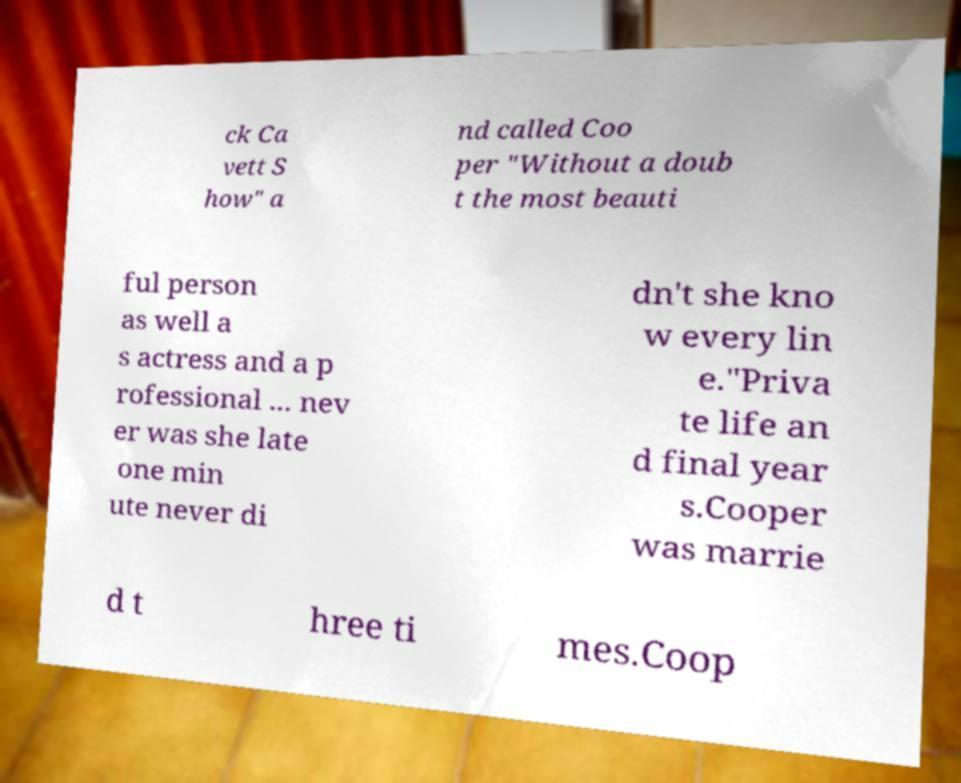Can you accurately transcribe the text from the provided image for me? ck Ca vett S how" a nd called Coo per "Without a doub t the most beauti ful person as well a s actress and a p rofessional ... nev er was she late one min ute never di dn't she kno w every lin e."Priva te life an d final year s.Cooper was marrie d t hree ti mes.Coop 